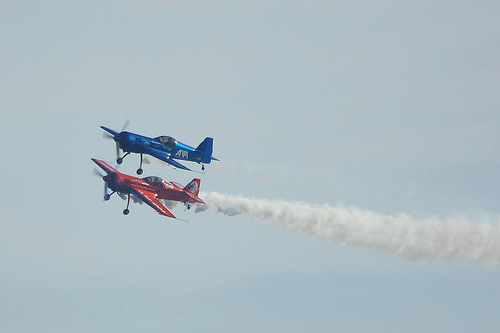How many of the airplanes have entrails? 1 